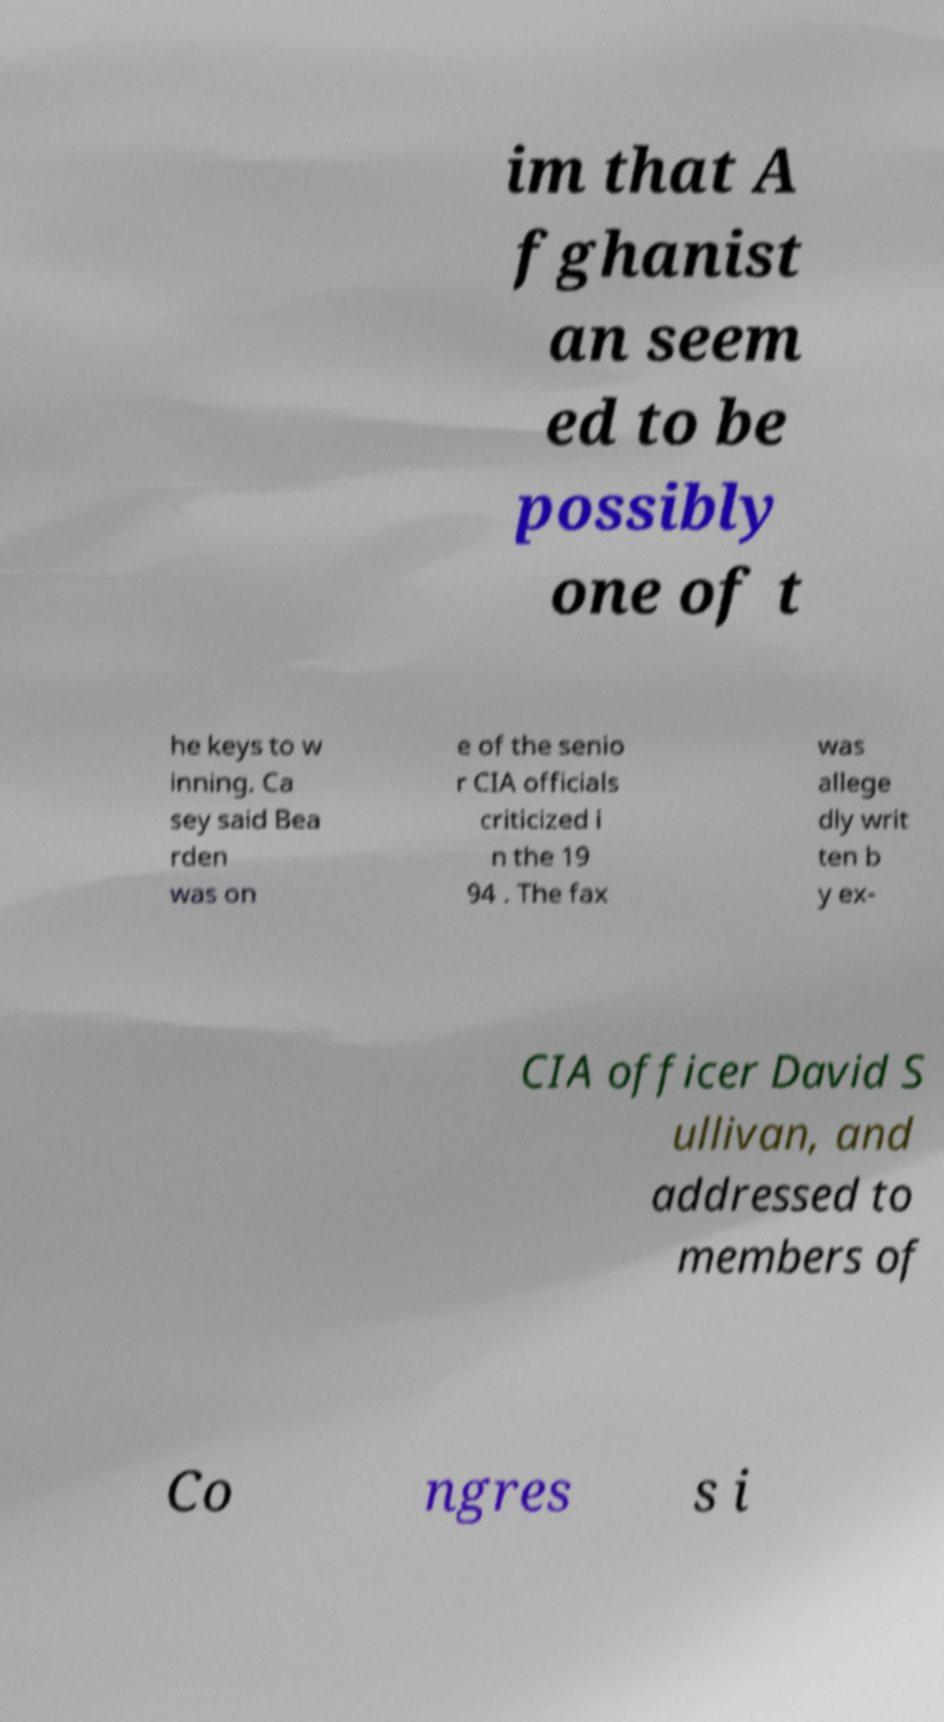What messages or text are displayed in this image? I need them in a readable, typed format. im that A fghanist an seem ed to be possibly one of t he keys to w inning. Ca sey said Bea rden was on e of the senio r CIA officials criticized i n the 19 94 . The fax was allege dly writ ten b y ex- CIA officer David S ullivan, and addressed to members of Co ngres s i 